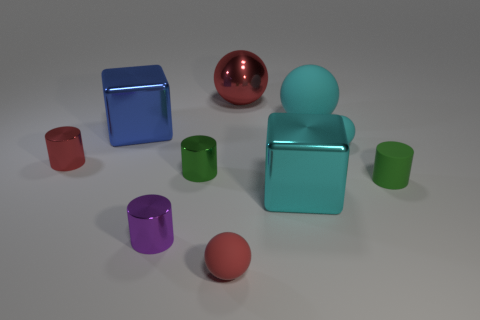While the objects appear inanimate, can you imagine a story they might be a part of? Certainly! In a realm of geometric shapes, the green cylinder could be a wise elder, the red sphere a wandering hero, and the paired blue cubes loyal sidekicks on an adventurous quest for the lost toruses of harmony. Can you tell me what time of day it appears to be based on the lighting in the image? The even, diffuse lighting with minimal shadows suggests an indoor setting with artificial light, rather than a time of day. 